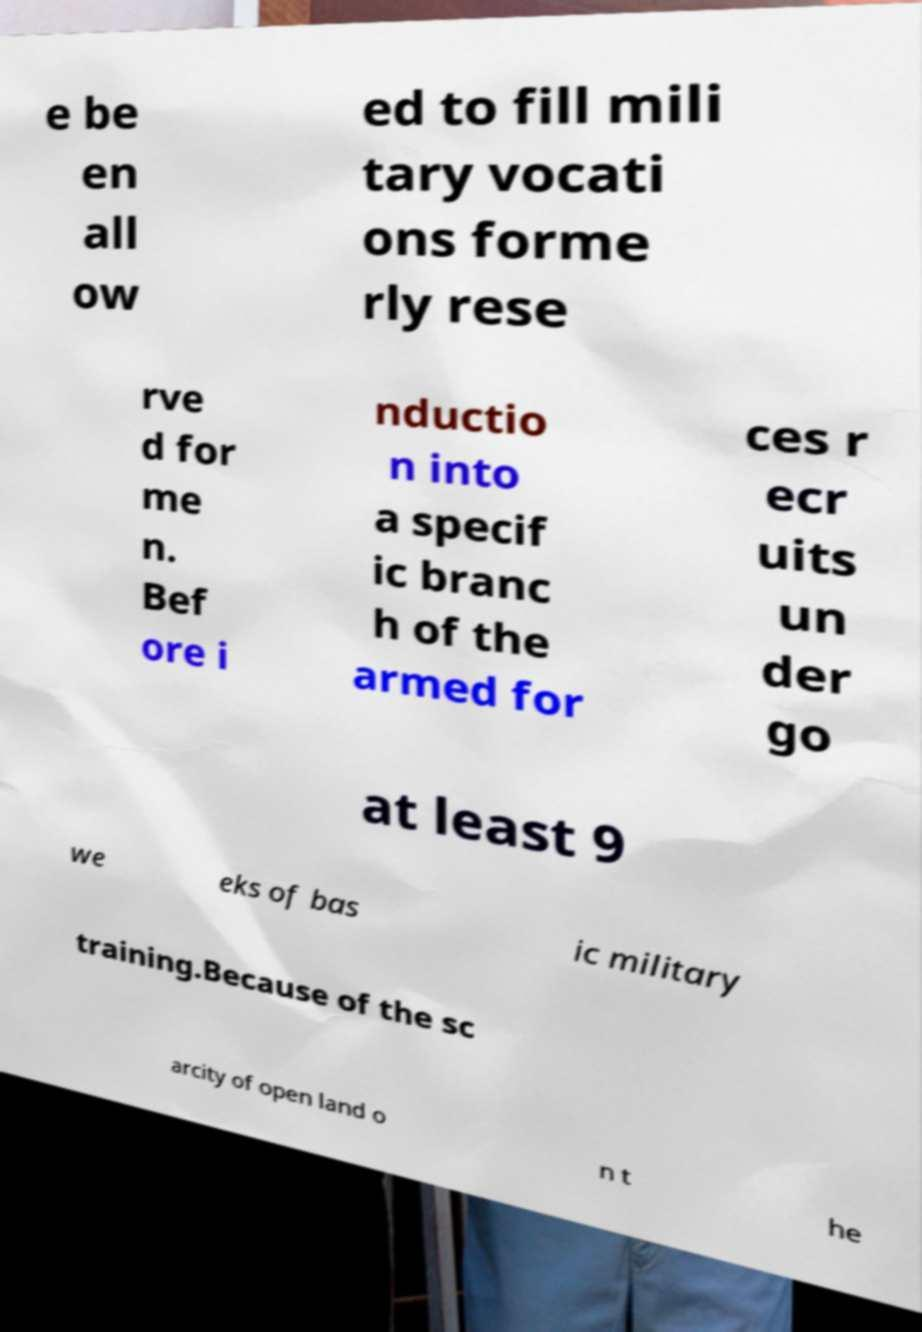For documentation purposes, I need the text within this image transcribed. Could you provide that? e be en all ow ed to fill mili tary vocati ons forme rly rese rve d for me n. Bef ore i nductio n into a specif ic branc h of the armed for ces r ecr uits un der go at least 9 we eks of bas ic military training.Because of the sc arcity of open land o n t he 